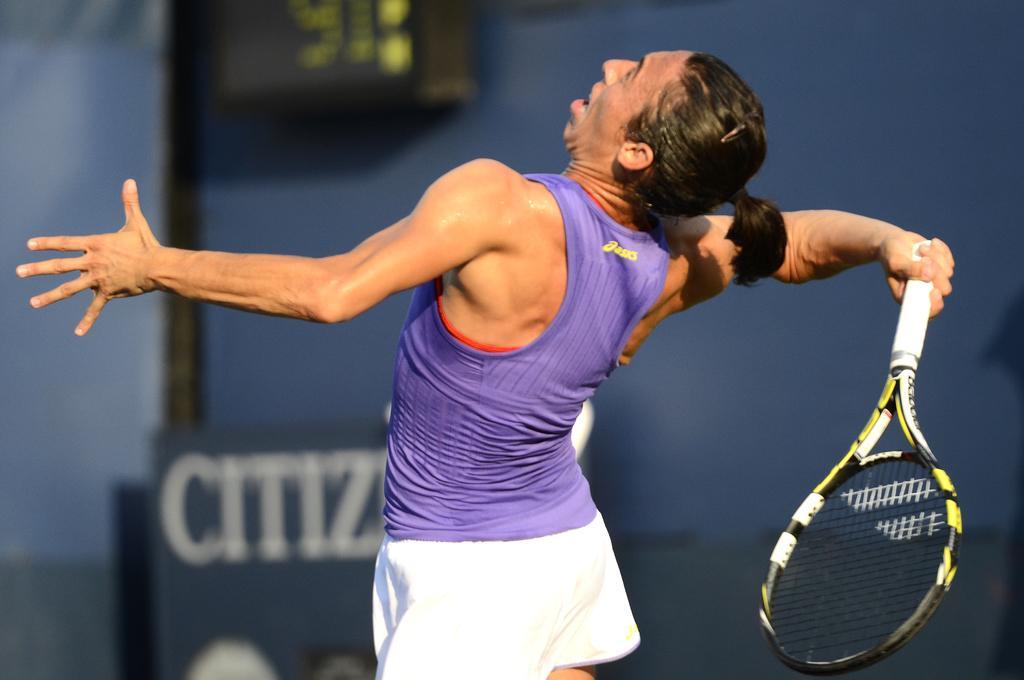Describe this image in one or two sentences. This is the picture of a sports person who is holding a bat is in violet top and white shorts in short hair. 